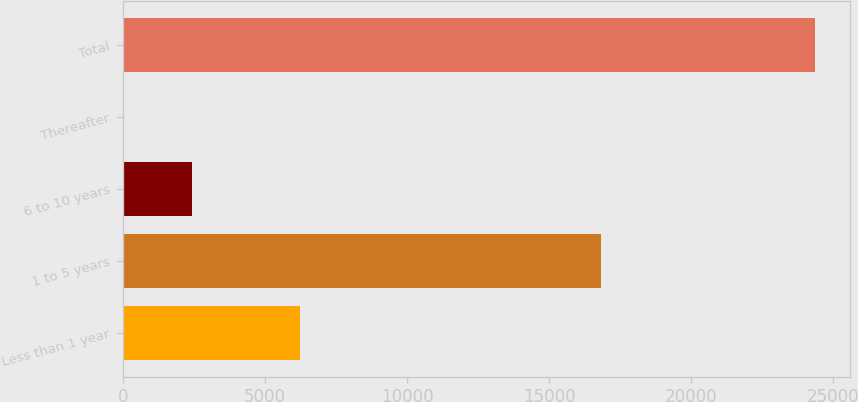<chart> <loc_0><loc_0><loc_500><loc_500><bar_chart><fcel>Less than 1 year<fcel>1 to 5 years<fcel>6 to 10 years<fcel>Thereafter<fcel>Total<nl><fcel>6241<fcel>16824<fcel>2437.45<fcel>1.61<fcel>24360<nl></chart> 